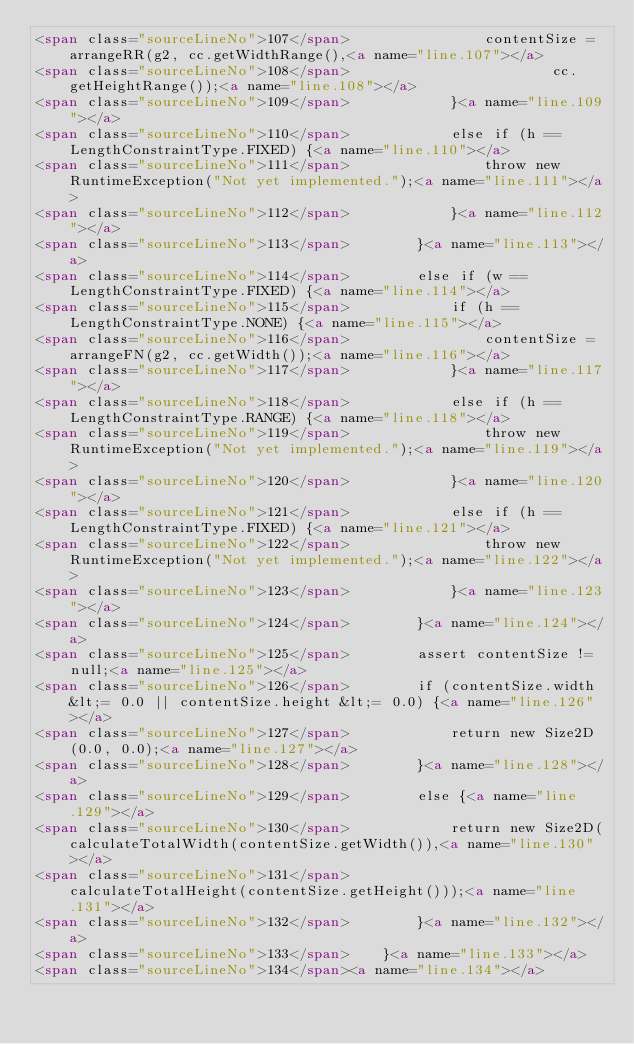<code> <loc_0><loc_0><loc_500><loc_500><_HTML_><span class="sourceLineNo">107</span>                contentSize = arrangeRR(g2, cc.getWidthRange(),<a name="line.107"></a>
<span class="sourceLineNo">108</span>                        cc.getHeightRange());<a name="line.108"></a>
<span class="sourceLineNo">109</span>            }<a name="line.109"></a>
<span class="sourceLineNo">110</span>            else if (h == LengthConstraintType.FIXED) {<a name="line.110"></a>
<span class="sourceLineNo">111</span>                throw new RuntimeException("Not yet implemented.");<a name="line.111"></a>
<span class="sourceLineNo">112</span>            }<a name="line.112"></a>
<span class="sourceLineNo">113</span>        }<a name="line.113"></a>
<span class="sourceLineNo">114</span>        else if (w == LengthConstraintType.FIXED) {<a name="line.114"></a>
<span class="sourceLineNo">115</span>            if (h == LengthConstraintType.NONE) {<a name="line.115"></a>
<span class="sourceLineNo">116</span>                contentSize = arrangeFN(g2, cc.getWidth());<a name="line.116"></a>
<span class="sourceLineNo">117</span>            }<a name="line.117"></a>
<span class="sourceLineNo">118</span>            else if (h == LengthConstraintType.RANGE) {<a name="line.118"></a>
<span class="sourceLineNo">119</span>                throw new RuntimeException("Not yet implemented.");<a name="line.119"></a>
<span class="sourceLineNo">120</span>            }<a name="line.120"></a>
<span class="sourceLineNo">121</span>            else if (h == LengthConstraintType.FIXED) {<a name="line.121"></a>
<span class="sourceLineNo">122</span>                throw new RuntimeException("Not yet implemented.");<a name="line.122"></a>
<span class="sourceLineNo">123</span>            }<a name="line.123"></a>
<span class="sourceLineNo">124</span>        }<a name="line.124"></a>
<span class="sourceLineNo">125</span>        assert contentSize != null;<a name="line.125"></a>
<span class="sourceLineNo">126</span>        if (contentSize.width &lt;= 0.0 || contentSize.height &lt;= 0.0) {<a name="line.126"></a>
<span class="sourceLineNo">127</span>            return new Size2D(0.0, 0.0);<a name="line.127"></a>
<span class="sourceLineNo">128</span>        }<a name="line.128"></a>
<span class="sourceLineNo">129</span>        else {<a name="line.129"></a>
<span class="sourceLineNo">130</span>            return new Size2D(calculateTotalWidth(contentSize.getWidth()),<a name="line.130"></a>
<span class="sourceLineNo">131</span>                    calculateTotalHeight(contentSize.getHeight()));<a name="line.131"></a>
<span class="sourceLineNo">132</span>        }<a name="line.132"></a>
<span class="sourceLineNo">133</span>    }<a name="line.133"></a>
<span class="sourceLineNo">134</span><a name="line.134"></a></code> 